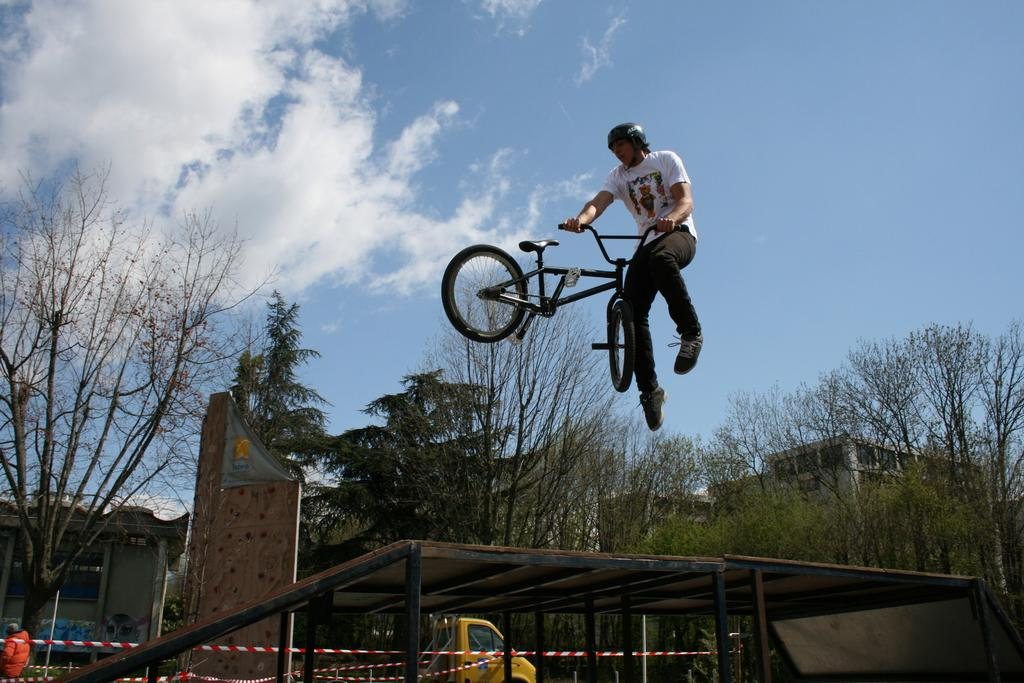What is the man in the image doing? The man is performing stunts with a cycle in the image. What is located at the bottom of the image? There is a table at the bottom of the image. What can be seen in the background of the image? There are trees, buildings, a vehicle, and the sky visible in the background of the image. What type of crate is being used to transport the fog in the image? There is no crate or fog present in the image. 